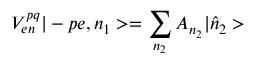<formula> <loc_0><loc_0><loc_500><loc_500>V _ { e n } ^ { p q } | - p e , n _ { 1 } > = \sum _ { n _ { 2 } } A _ { n _ { 2 } } | \hat { n } _ { 2 } ></formula> 